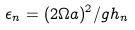Convert formula to latex. <formula><loc_0><loc_0><loc_500><loc_500>\epsilon _ { n } = ( 2 \Omega a ) ^ { 2 } / g h _ { n }</formula> 